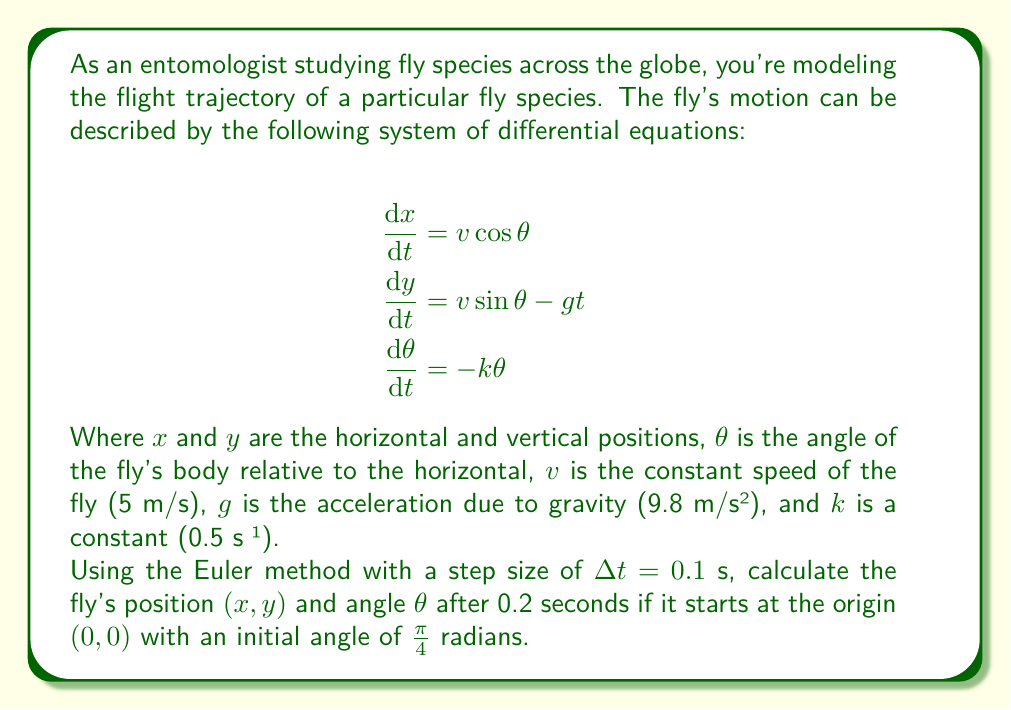What is the answer to this math problem? To solve this problem using the Euler method, we'll follow these steps:

1) The Euler method for a system of differential equations is given by:
   $$x_{n+1} = x_n + \Delta t \cdot f(x_n, y_n, \theta_n)$$
   $$y_{n+1} = y_n + \Delta t \cdot g(x_n, y_n, \theta_n)$$
   $$\theta_{n+1} = \theta_n + \Delta t \cdot h(x_n, y_n, \theta_n)$$

2) In our case:
   $$f(x, y, \theta) = v\cos\theta$$
   $$g(x, y, \theta) = v\sin\theta - gt$$
   $$h(x, y, \theta) = -k\theta$$

3) Initial conditions:
   $x_0 = 0$, $y_0 = 0$, $\theta_0 = \frac{\pi}{4}$, $t_0 = 0$

4) For the first step ($n = 0$, $t = 0.1$):
   $$x_1 = 0 + 0.1 \cdot (5 \cos(\frac{\pi}{4})) = 0.3536$$
   $$y_1 = 0 + 0.1 \cdot (5 \sin(\frac{\pi}{4}) - 9.8 \cdot 0) = 0.3536$$
   $$\theta_1 = \frac{\pi}{4} + 0.1 \cdot (-0.5 \cdot \frac{\pi}{4}) = 0.7068$$

5) For the second step ($n = 1$, $t = 0.2$):
   $$x_2 = 0.3536 + 0.1 \cdot (5 \cos(0.7068)) = 0.7103$$
   $$y_2 = 0.3536 + 0.1 \cdot (5 \sin(0.7068) - 9.8 \cdot 0.1) = 0.6105$$
   $$\theta_2 = 0.7068 + 0.1 \cdot (-0.5 \cdot 0.7068) = 0.6715$$

Therefore, after 0.2 seconds, the fly's position is approximately (0.7103, 0.6105) meters, and its angle is approximately 0.6715 radians.
Answer: (0.7103, 0.6105, 0.6715) 